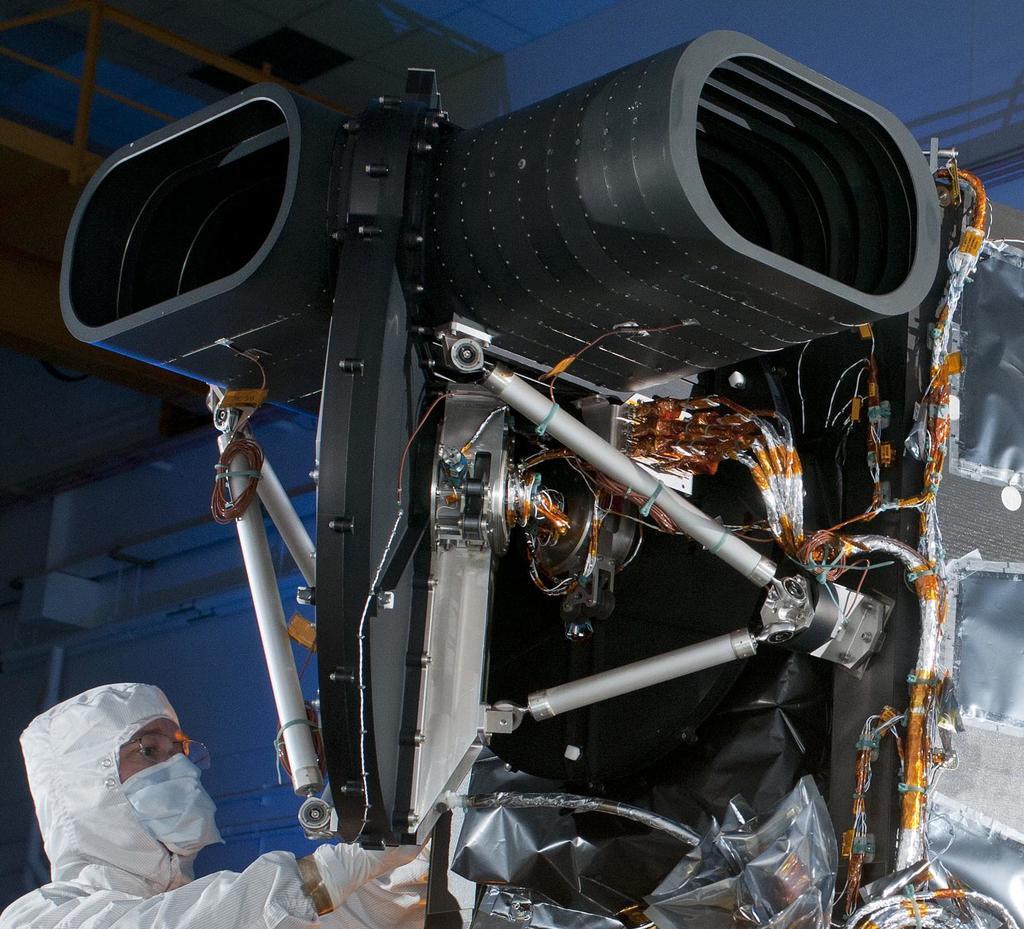Please provide a concise description of this image. In this image, we can see a mechanical and electrical instrument, there is a person standing. 